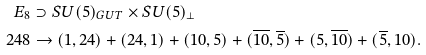<formula> <loc_0><loc_0><loc_500><loc_500>E _ { 8 } & \supset S U ( 5 ) _ { G U T } \times S U ( 5 ) _ { \bot } \\ 2 4 8 & \rightarrow ( 1 , 2 4 ) + ( 2 4 , 1 ) + ( 1 0 , 5 ) + ( \overline { 1 0 } , \overline { 5 } ) + ( 5 , \overline { 1 0 } ) + ( \overline { 5 } , 1 0 ) .</formula> 